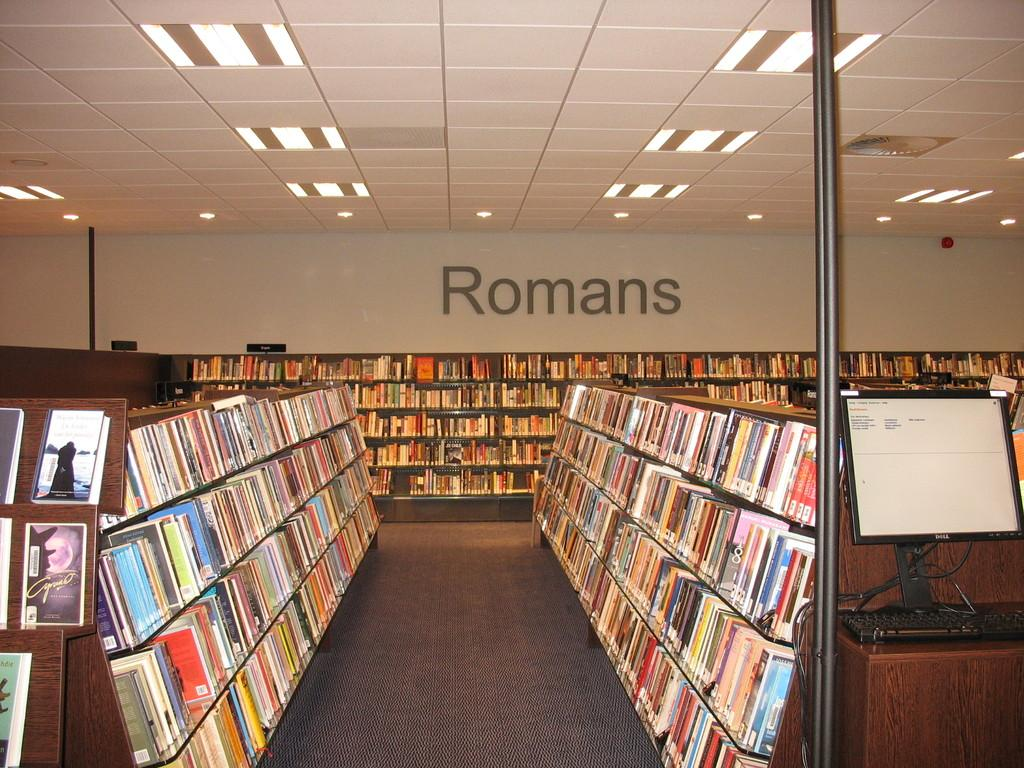What is the main object in the image? There is a rack of books in the image. What electronic devices are visible in the image? There is a monitor and a keyboard in the image. What architectural features can be seen in the background of the image? There are poles, a wall, a ceiling, and lights in the background of the image. Can you see the seashore in the background of the image? No, there is no seashore present in the image. The background features a wall, ceiling, and lights, but not a seashore. 